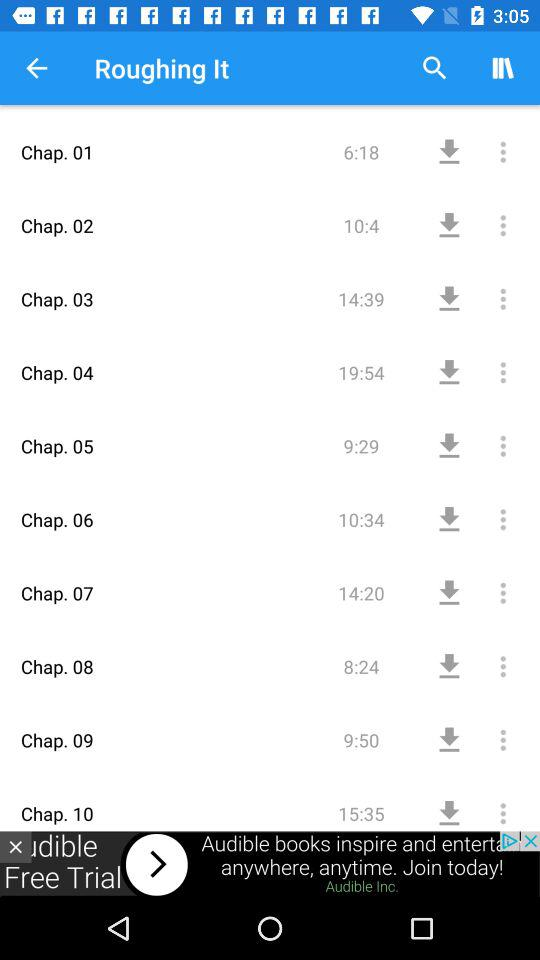How many chapters are there in the book?
Answer the question using a single word or phrase. 10 